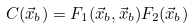<formula> <loc_0><loc_0><loc_500><loc_500>C ( \vec { x } _ { b } ) = F _ { 1 } ( \vec { x } _ { b } , \vec { x } _ { b } ) F _ { 2 } ( \vec { x } _ { b } )</formula> 